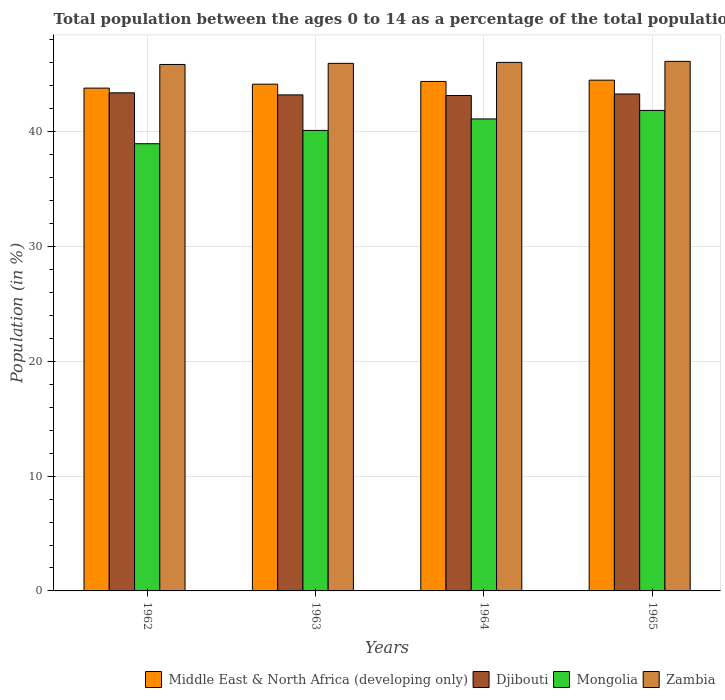How many different coloured bars are there?
Make the answer very short. 4. How many groups of bars are there?
Give a very brief answer. 4. Are the number of bars per tick equal to the number of legend labels?
Offer a very short reply. Yes. How many bars are there on the 1st tick from the left?
Keep it short and to the point. 4. How many bars are there on the 1st tick from the right?
Offer a very short reply. 4. What is the label of the 3rd group of bars from the left?
Make the answer very short. 1964. In how many cases, is the number of bars for a given year not equal to the number of legend labels?
Offer a terse response. 0. What is the percentage of the population ages 0 to 14 in Middle East & North Africa (developing only) in 1962?
Provide a succinct answer. 43.8. Across all years, what is the maximum percentage of the population ages 0 to 14 in Djibouti?
Your response must be concise. 43.39. Across all years, what is the minimum percentage of the population ages 0 to 14 in Zambia?
Offer a very short reply. 45.86. In which year was the percentage of the population ages 0 to 14 in Mongolia maximum?
Provide a succinct answer. 1965. What is the total percentage of the population ages 0 to 14 in Mongolia in the graph?
Your answer should be very brief. 162.06. What is the difference between the percentage of the population ages 0 to 14 in Middle East & North Africa (developing only) in 1964 and that in 1965?
Provide a short and direct response. -0.11. What is the difference between the percentage of the population ages 0 to 14 in Zambia in 1962 and the percentage of the population ages 0 to 14 in Djibouti in 1964?
Provide a succinct answer. 2.7. What is the average percentage of the population ages 0 to 14 in Middle East & North Africa (developing only) per year?
Offer a terse response. 44.21. In the year 1964, what is the difference between the percentage of the population ages 0 to 14 in Zambia and percentage of the population ages 0 to 14 in Middle East & North Africa (developing only)?
Provide a succinct answer. 1.66. What is the ratio of the percentage of the population ages 0 to 14 in Djibouti in 1962 to that in 1963?
Your answer should be very brief. 1. Is the percentage of the population ages 0 to 14 in Middle East & North Africa (developing only) in 1963 less than that in 1965?
Your response must be concise. Yes. What is the difference between the highest and the second highest percentage of the population ages 0 to 14 in Zambia?
Provide a short and direct response. 0.09. What is the difference between the highest and the lowest percentage of the population ages 0 to 14 in Djibouti?
Keep it short and to the point. 0.23. Is it the case that in every year, the sum of the percentage of the population ages 0 to 14 in Mongolia and percentage of the population ages 0 to 14 in Djibouti is greater than the sum of percentage of the population ages 0 to 14 in Zambia and percentage of the population ages 0 to 14 in Middle East & North Africa (developing only)?
Give a very brief answer. No. What does the 3rd bar from the left in 1965 represents?
Your answer should be very brief. Mongolia. What does the 2nd bar from the right in 1964 represents?
Offer a terse response. Mongolia. How many bars are there?
Your response must be concise. 16. Are all the bars in the graph horizontal?
Provide a short and direct response. No. Does the graph contain any zero values?
Your response must be concise. No. Does the graph contain grids?
Keep it short and to the point. Yes. Where does the legend appear in the graph?
Provide a short and direct response. Bottom right. How many legend labels are there?
Provide a short and direct response. 4. What is the title of the graph?
Give a very brief answer. Total population between the ages 0 to 14 as a percentage of the total population. What is the label or title of the X-axis?
Offer a very short reply. Years. What is the Population (in %) in Middle East & North Africa (developing only) in 1962?
Offer a very short reply. 43.8. What is the Population (in %) in Djibouti in 1962?
Offer a terse response. 43.39. What is the Population (in %) of Mongolia in 1962?
Provide a succinct answer. 38.96. What is the Population (in %) in Zambia in 1962?
Your answer should be very brief. 45.86. What is the Population (in %) in Middle East & North Africa (developing only) in 1963?
Make the answer very short. 44.15. What is the Population (in %) in Djibouti in 1963?
Offer a very short reply. 43.21. What is the Population (in %) of Mongolia in 1963?
Ensure brevity in your answer.  40.12. What is the Population (in %) of Zambia in 1963?
Make the answer very short. 45.96. What is the Population (in %) of Middle East & North Africa (developing only) in 1964?
Your answer should be compact. 44.38. What is the Population (in %) of Djibouti in 1964?
Keep it short and to the point. 43.16. What is the Population (in %) of Mongolia in 1964?
Keep it short and to the point. 41.12. What is the Population (in %) in Zambia in 1964?
Keep it short and to the point. 46.05. What is the Population (in %) of Middle East & North Africa (developing only) in 1965?
Give a very brief answer. 44.5. What is the Population (in %) in Djibouti in 1965?
Provide a succinct answer. 43.29. What is the Population (in %) of Mongolia in 1965?
Your answer should be compact. 41.86. What is the Population (in %) in Zambia in 1965?
Keep it short and to the point. 46.13. Across all years, what is the maximum Population (in %) in Middle East & North Africa (developing only)?
Offer a very short reply. 44.5. Across all years, what is the maximum Population (in %) in Djibouti?
Offer a very short reply. 43.39. Across all years, what is the maximum Population (in %) in Mongolia?
Your answer should be compact. 41.86. Across all years, what is the maximum Population (in %) in Zambia?
Offer a very short reply. 46.13. Across all years, what is the minimum Population (in %) in Middle East & North Africa (developing only)?
Ensure brevity in your answer.  43.8. Across all years, what is the minimum Population (in %) of Djibouti?
Provide a short and direct response. 43.16. Across all years, what is the minimum Population (in %) in Mongolia?
Provide a short and direct response. 38.96. Across all years, what is the minimum Population (in %) in Zambia?
Give a very brief answer. 45.86. What is the total Population (in %) of Middle East & North Africa (developing only) in the graph?
Keep it short and to the point. 176.83. What is the total Population (in %) of Djibouti in the graph?
Your answer should be very brief. 173.06. What is the total Population (in %) in Mongolia in the graph?
Your response must be concise. 162.06. What is the total Population (in %) of Zambia in the graph?
Provide a succinct answer. 184. What is the difference between the Population (in %) in Middle East & North Africa (developing only) in 1962 and that in 1963?
Give a very brief answer. -0.34. What is the difference between the Population (in %) of Djibouti in 1962 and that in 1963?
Your answer should be very brief. 0.18. What is the difference between the Population (in %) in Mongolia in 1962 and that in 1963?
Offer a terse response. -1.16. What is the difference between the Population (in %) in Zambia in 1962 and that in 1963?
Keep it short and to the point. -0.1. What is the difference between the Population (in %) of Middle East & North Africa (developing only) in 1962 and that in 1964?
Your answer should be compact. -0.58. What is the difference between the Population (in %) in Djibouti in 1962 and that in 1964?
Offer a terse response. 0.23. What is the difference between the Population (in %) in Mongolia in 1962 and that in 1964?
Give a very brief answer. -2.16. What is the difference between the Population (in %) in Zambia in 1962 and that in 1964?
Give a very brief answer. -0.18. What is the difference between the Population (in %) of Middle East & North Africa (developing only) in 1962 and that in 1965?
Offer a very short reply. -0.69. What is the difference between the Population (in %) of Djibouti in 1962 and that in 1965?
Your response must be concise. 0.1. What is the difference between the Population (in %) in Mongolia in 1962 and that in 1965?
Your answer should be very brief. -2.9. What is the difference between the Population (in %) of Zambia in 1962 and that in 1965?
Provide a succinct answer. -0.27. What is the difference between the Population (in %) in Middle East & North Africa (developing only) in 1963 and that in 1964?
Provide a short and direct response. -0.24. What is the difference between the Population (in %) of Djibouti in 1963 and that in 1964?
Ensure brevity in your answer.  0.05. What is the difference between the Population (in %) in Mongolia in 1963 and that in 1964?
Give a very brief answer. -1. What is the difference between the Population (in %) in Zambia in 1963 and that in 1964?
Give a very brief answer. -0.09. What is the difference between the Population (in %) of Middle East & North Africa (developing only) in 1963 and that in 1965?
Keep it short and to the point. -0.35. What is the difference between the Population (in %) in Djibouti in 1963 and that in 1965?
Give a very brief answer. -0.08. What is the difference between the Population (in %) in Mongolia in 1963 and that in 1965?
Keep it short and to the point. -1.74. What is the difference between the Population (in %) of Zambia in 1963 and that in 1965?
Keep it short and to the point. -0.17. What is the difference between the Population (in %) of Middle East & North Africa (developing only) in 1964 and that in 1965?
Keep it short and to the point. -0.11. What is the difference between the Population (in %) in Djibouti in 1964 and that in 1965?
Offer a terse response. -0.13. What is the difference between the Population (in %) of Mongolia in 1964 and that in 1965?
Offer a terse response. -0.74. What is the difference between the Population (in %) in Zambia in 1964 and that in 1965?
Your response must be concise. -0.09. What is the difference between the Population (in %) in Middle East & North Africa (developing only) in 1962 and the Population (in %) in Djibouti in 1963?
Your answer should be very brief. 0.59. What is the difference between the Population (in %) of Middle East & North Africa (developing only) in 1962 and the Population (in %) of Mongolia in 1963?
Offer a very short reply. 3.69. What is the difference between the Population (in %) of Middle East & North Africa (developing only) in 1962 and the Population (in %) of Zambia in 1963?
Your answer should be compact. -2.16. What is the difference between the Population (in %) in Djibouti in 1962 and the Population (in %) in Mongolia in 1963?
Offer a terse response. 3.27. What is the difference between the Population (in %) of Djibouti in 1962 and the Population (in %) of Zambia in 1963?
Offer a terse response. -2.57. What is the difference between the Population (in %) in Mongolia in 1962 and the Population (in %) in Zambia in 1963?
Offer a terse response. -7. What is the difference between the Population (in %) of Middle East & North Africa (developing only) in 1962 and the Population (in %) of Djibouti in 1964?
Your answer should be compact. 0.64. What is the difference between the Population (in %) of Middle East & North Africa (developing only) in 1962 and the Population (in %) of Mongolia in 1964?
Ensure brevity in your answer.  2.68. What is the difference between the Population (in %) of Middle East & North Africa (developing only) in 1962 and the Population (in %) of Zambia in 1964?
Provide a succinct answer. -2.24. What is the difference between the Population (in %) of Djibouti in 1962 and the Population (in %) of Mongolia in 1964?
Ensure brevity in your answer.  2.27. What is the difference between the Population (in %) of Djibouti in 1962 and the Population (in %) of Zambia in 1964?
Make the answer very short. -2.65. What is the difference between the Population (in %) of Mongolia in 1962 and the Population (in %) of Zambia in 1964?
Offer a terse response. -7.09. What is the difference between the Population (in %) in Middle East & North Africa (developing only) in 1962 and the Population (in %) in Djibouti in 1965?
Offer a terse response. 0.51. What is the difference between the Population (in %) in Middle East & North Africa (developing only) in 1962 and the Population (in %) in Mongolia in 1965?
Your answer should be compact. 1.94. What is the difference between the Population (in %) in Middle East & North Africa (developing only) in 1962 and the Population (in %) in Zambia in 1965?
Give a very brief answer. -2.33. What is the difference between the Population (in %) of Djibouti in 1962 and the Population (in %) of Mongolia in 1965?
Make the answer very short. 1.53. What is the difference between the Population (in %) of Djibouti in 1962 and the Population (in %) of Zambia in 1965?
Provide a short and direct response. -2.74. What is the difference between the Population (in %) of Mongolia in 1962 and the Population (in %) of Zambia in 1965?
Your response must be concise. -7.18. What is the difference between the Population (in %) in Middle East & North Africa (developing only) in 1963 and the Population (in %) in Djibouti in 1964?
Your answer should be very brief. 0.99. What is the difference between the Population (in %) in Middle East & North Africa (developing only) in 1963 and the Population (in %) in Mongolia in 1964?
Your answer should be very brief. 3.03. What is the difference between the Population (in %) in Middle East & North Africa (developing only) in 1963 and the Population (in %) in Zambia in 1964?
Your answer should be compact. -1.9. What is the difference between the Population (in %) in Djibouti in 1963 and the Population (in %) in Mongolia in 1964?
Offer a terse response. 2.09. What is the difference between the Population (in %) in Djibouti in 1963 and the Population (in %) in Zambia in 1964?
Ensure brevity in your answer.  -2.83. What is the difference between the Population (in %) in Mongolia in 1963 and the Population (in %) in Zambia in 1964?
Make the answer very short. -5.93. What is the difference between the Population (in %) in Middle East & North Africa (developing only) in 1963 and the Population (in %) in Djibouti in 1965?
Provide a succinct answer. 0.86. What is the difference between the Population (in %) in Middle East & North Africa (developing only) in 1963 and the Population (in %) in Mongolia in 1965?
Provide a short and direct response. 2.29. What is the difference between the Population (in %) of Middle East & North Africa (developing only) in 1963 and the Population (in %) of Zambia in 1965?
Keep it short and to the point. -1.99. What is the difference between the Population (in %) of Djibouti in 1963 and the Population (in %) of Mongolia in 1965?
Offer a very short reply. 1.35. What is the difference between the Population (in %) in Djibouti in 1963 and the Population (in %) in Zambia in 1965?
Your answer should be very brief. -2.92. What is the difference between the Population (in %) in Mongolia in 1963 and the Population (in %) in Zambia in 1965?
Your answer should be very brief. -6.02. What is the difference between the Population (in %) of Middle East & North Africa (developing only) in 1964 and the Population (in %) of Djibouti in 1965?
Offer a terse response. 1.09. What is the difference between the Population (in %) of Middle East & North Africa (developing only) in 1964 and the Population (in %) of Mongolia in 1965?
Offer a terse response. 2.52. What is the difference between the Population (in %) of Middle East & North Africa (developing only) in 1964 and the Population (in %) of Zambia in 1965?
Provide a short and direct response. -1.75. What is the difference between the Population (in %) of Djibouti in 1964 and the Population (in %) of Mongolia in 1965?
Your answer should be very brief. 1.3. What is the difference between the Population (in %) of Djibouti in 1964 and the Population (in %) of Zambia in 1965?
Your answer should be compact. -2.98. What is the difference between the Population (in %) of Mongolia in 1964 and the Population (in %) of Zambia in 1965?
Your response must be concise. -5.02. What is the average Population (in %) in Middle East & North Africa (developing only) per year?
Offer a terse response. 44.21. What is the average Population (in %) in Djibouti per year?
Make the answer very short. 43.26. What is the average Population (in %) in Mongolia per year?
Offer a very short reply. 40.51. What is the average Population (in %) in Zambia per year?
Ensure brevity in your answer.  46. In the year 1962, what is the difference between the Population (in %) of Middle East & North Africa (developing only) and Population (in %) of Djibouti?
Your answer should be compact. 0.41. In the year 1962, what is the difference between the Population (in %) of Middle East & North Africa (developing only) and Population (in %) of Mongolia?
Make the answer very short. 4.84. In the year 1962, what is the difference between the Population (in %) of Middle East & North Africa (developing only) and Population (in %) of Zambia?
Provide a succinct answer. -2.06. In the year 1962, what is the difference between the Population (in %) of Djibouti and Population (in %) of Mongolia?
Make the answer very short. 4.43. In the year 1962, what is the difference between the Population (in %) in Djibouti and Population (in %) in Zambia?
Your answer should be very brief. -2.47. In the year 1962, what is the difference between the Population (in %) in Mongolia and Population (in %) in Zambia?
Your answer should be compact. -6.9. In the year 1963, what is the difference between the Population (in %) in Middle East & North Africa (developing only) and Population (in %) in Djibouti?
Offer a very short reply. 0.93. In the year 1963, what is the difference between the Population (in %) of Middle East & North Africa (developing only) and Population (in %) of Mongolia?
Your response must be concise. 4.03. In the year 1963, what is the difference between the Population (in %) of Middle East & North Africa (developing only) and Population (in %) of Zambia?
Your answer should be compact. -1.81. In the year 1963, what is the difference between the Population (in %) of Djibouti and Population (in %) of Mongolia?
Your answer should be compact. 3.1. In the year 1963, what is the difference between the Population (in %) in Djibouti and Population (in %) in Zambia?
Ensure brevity in your answer.  -2.75. In the year 1963, what is the difference between the Population (in %) in Mongolia and Population (in %) in Zambia?
Ensure brevity in your answer.  -5.84. In the year 1964, what is the difference between the Population (in %) of Middle East & North Africa (developing only) and Population (in %) of Djibouti?
Your response must be concise. 1.22. In the year 1964, what is the difference between the Population (in %) in Middle East & North Africa (developing only) and Population (in %) in Mongolia?
Offer a very short reply. 3.27. In the year 1964, what is the difference between the Population (in %) of Middle East & North Africa (developing only) and Population (in %) of Zambia?
Provide a succinct answer. -1.66. In the year 1964, what is the difference between the Population (in %) of Djibouti and Population (in %) of Mongolia?
Your answer should be very brief. 2.04. In the year 1964, what is the difference between the Population (in %) in Djibouti and Population (in %) in Zambia?
Your answer should be compact. -2.89. In the year 1964, what is the difference between the Population (in %) of Mongolia and Population (in %) of Zambia?
Offer a very short reply. -4.93. In the year 1965, what is the difference between the Population (in %) in Middle East & North Africa (developing only) and Population (in %) in Djibouti?
Your answer should be very brief. 1.2. In the year 1965, what is the difference between the Population (in %) in Middle East & North Africa (developing only) and Population (in %) in Mongolia?
Your answer should be very brief. 2.64. In the year 1965, what is the difference between the Population (in %) in Middle East & North Africa (developing only) and Population (in %) in Zambia?
Your answer should be compact. -1.64. In the year 1965, what is the difference between the Population (in %) in Djibouti and Population (in %) in Mongolia?
Provide a succinct answer. 1.43. In the year 1965, what is the difference between the Population (in %) of Djibouti and Population (in %) of Zambia?
Your answer should be very brief. -2.84. In the year 1965, what is the difference between the Population (in %) in Mongolia and Population (in %) in Zambia?
Your response must be concise. -4.27. What is the ratio of the Population (in %) in Middle East & North Africa (developing only) in 1962 to that in 1963?
Your response must be concise. 0.99. What is the ratio of the Population (in %) in Djibouti in 1962 to that in 1963?
Provide a succinct answer. 1. What is the ratio of the Population (in %) in Mongolia in 1962 to that in 1963?
Your response must be concise. 0.97. What is the ratio of the Population (in %) in Zambia in 1962 to that in 1963?
Ensure brevity in your answer.  1. What is the ratio of the Population (in %) in Middle East & North Africa (developing only) in 1962 to that in 1964?
Ensure brevity in your answer.  0.99. What is the ratio of the Population (in %) of Djibouti in 1962 to that in 1964?
Keep it short and to the point. 1.01. What is the ratio of the Population (in %) of Mongolia in 1962 to that in 1964?
Ensure brevity in your answer.  0.95. What is the ratio of the Population (in %) of Middle East & North Africa (developing only) in 1962 to that in 1965?
Provide a succinct answer. 0.98. What is the ratio of the Population (in %) in Djibouti in 1962 to that in 1965?
Keep it short and to the point. 1. What is the ratio of the Population (in %) in Mongolia in 1962 to that in 1965?
Provide a short and direct response. 0.93. What is the ratio of the Population (in %) of Zambia in 1962 to that in 1965?
Keep it short and to the point. 0.99. What is the ratio of the Population (in %) in Middle East & North Africa (developing only) in 1963 to that in 1964?
Provide a short and direct response. 0.99. What is the ratio of the Population (in %) in Mongolia in 1963 to that in 1964?
Make the answer very short. 0.98. What is the ratio of the Population (in %) in Mongolia in 1963 to that in 1965?
Your response must be concise. 0.96. What is the ratio of the Population (in %) in Zambia in 1963 to that in 1965?
Your answer should be very brief. 1. What is the ratio of the Population (in %) in Middle East & North Africa (developing only) in 1964 to that in 1965?
Your answer should be very brief. 1. What is the ratio of the Population (in %) of Mongolia in 1964 to that in 1965?
Keep it short and to the point. 0.98. What is the difference between the highest and the second highest Population (in %) in Middle East & North Africa (developing only)?
Make the answer very short. 0.11. What is the difference between the highest and the second highest Population (in %) of Djibouti?
Ensure brevity in your answer.  0.1. What is the difference between the highest and the second highest Population (in %) in Mongolia?
Your response must be concise. 0.74. What is the difference between the highest and the second highest Population (in %) in Zambia?
Your response must be concise. 0.09. What is the difference between the highest and the lowest Population (in %) in Middle East & North Africa (developing only)?
Your answer should be very brief. 0.69. What is the difference between the highest and the lowest Population (in %) of Djibouti?
Provide a succinct answer. 0.23. What is the difference between the highest and the lowest Population (in %) of Mongolia?
Provide a short and direct response. 2.9. What is the difference between the highest and the lowest Population (in %) of Zambia?
Provide a short and direct response. 0.27. 